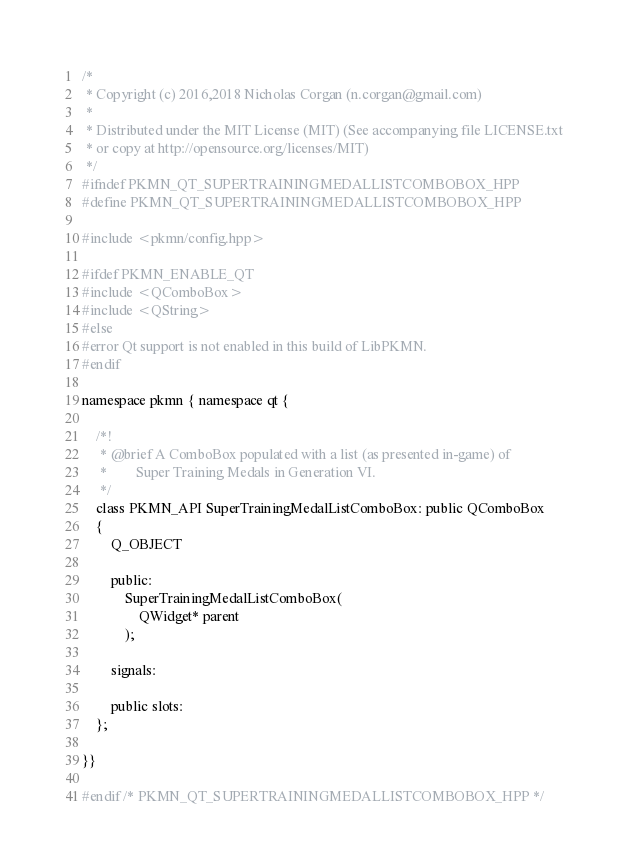<code> <loc_0><loc_0><loc_500><loc_500><_C++_>/*
 * Copyright (c) 2016,2018 Nicholas Corgan (n.corgan@gmail.com)
 *
 * Distributed under the MIT License (MIT) (See accompanying file LICENSE.txt
 * or copy at http://opensource.org/licenses/MIT)
 */
#ifndef PKMN_QT_SUPERTRAININGMEDALLISTCOMBOBOX_HPP
#define PKMN_QT_SUPERTRAININGMEDALLISTCOMBOBOX_HPP

#include <pkmn/config.hpp>

#ifdef PKMN_ENABLE_QT
#include <QComboBox>
#include <QString>
#else
#error Qt support is not enabled in this build of LibPKMN.
#endif

namespace pkmn { namespace qt {

    /*!
     * @brief A ComboBox populated with a list (as presented in-game) of
     *        Super Training Medals in Generation VI.
     */
    class PKMN_API SuperTrainingMedalListComboBox: public QComboBox
    {
        Q_OBJECT

        public:
            SuperTrainingMedalListComboBox(
                QWidget* parent
            );

        signals:

        public slots:
    };

}}

#endif /* PKMN_QT_SUPERTRAININGMEDALLISTCOMBOBOX_HPP */
</code> 